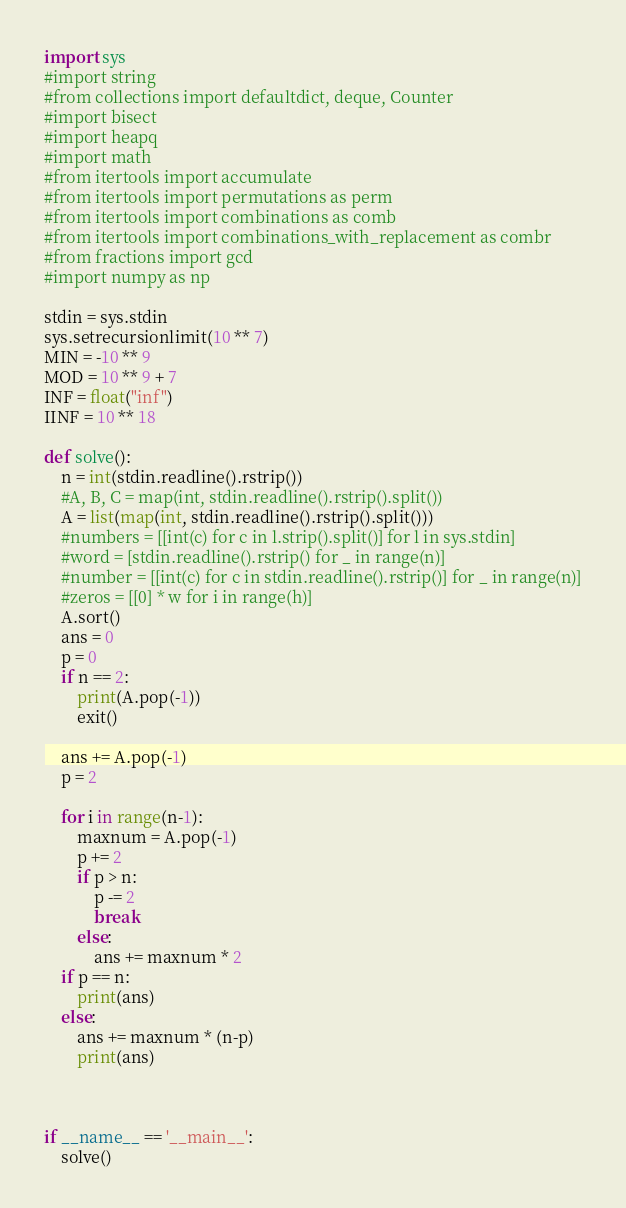<code> <loc_0><loc_0><loc_500><loc_500><_Python_>import sys
#import string
#from collections import defaultdict, deque, Counter
#import bisect
#import heapq
#import math
#from itertools import accumulate
#from itertools import permutations as perm
#from itertools import combinations as comb
#from itertools import combinations_with_replacement as combr
#from fractions import gcd
#import numpy as np

stdin = sys.stdin
sys.setrecursionlimit(10 ** 7)
MIN = -10 ** 9
MOD = 10 ** 9 + 7
INF = float("inf")
IINF = 10 ** 18

def solve():
    n = int(stdin.readline().rstrip())
    #A, B, C = map(int, stdin.readline().rstrip().split())
    A = list(map(int, stdin.readline().rstrip().split()))
    #numbers = [[int(c) for c in l.strip().split()] for l in sys.stdin]
    #word = [stdin.readline().rstrip() for _ in range(n)]
    #number = [[int(c) for c in stdin.readline().rstrip()] for _ in range(n)]
    #zeros = [[0] * w for i in range(h)]
    A.sort()
    ans = 0
    p = 0
    if n == 2:
        print(A.pop(-1))
        exit()

    ans += A.pop(-1)
    p = 2

    for i in range(n-1):
        maxnum = A.pop(-1)
        p += 2
        if p > n:
            p -= 2
            break
        else:
            ans += maxnum * 2
    if p == n:
        print(ans)
    else:
        ans += maxnum * (n-p)
        print(ans)



if __name__ == '__main__':
    solve()
</code> 